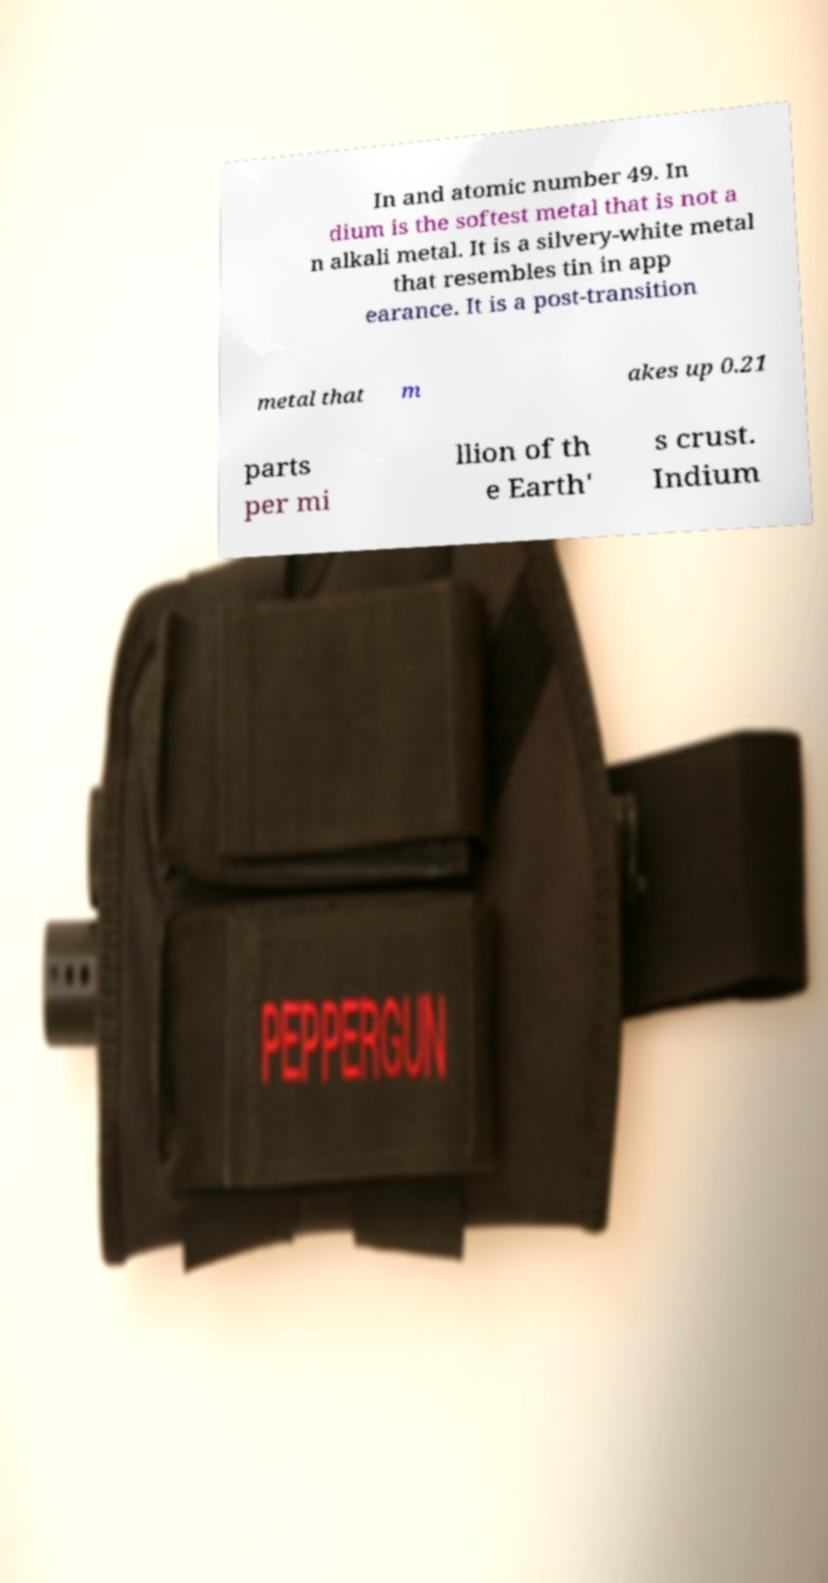I need the written content from this picture converted into text. Can you do that? In and atomic number 49. In dium is the softest metal that is not a n alkali metal. It is a silvery-white metal that resembles tin in app earance. It is a post-transition metal that m akes up 0.21 parts per mi llion of th e Earth' s crust. Indium 